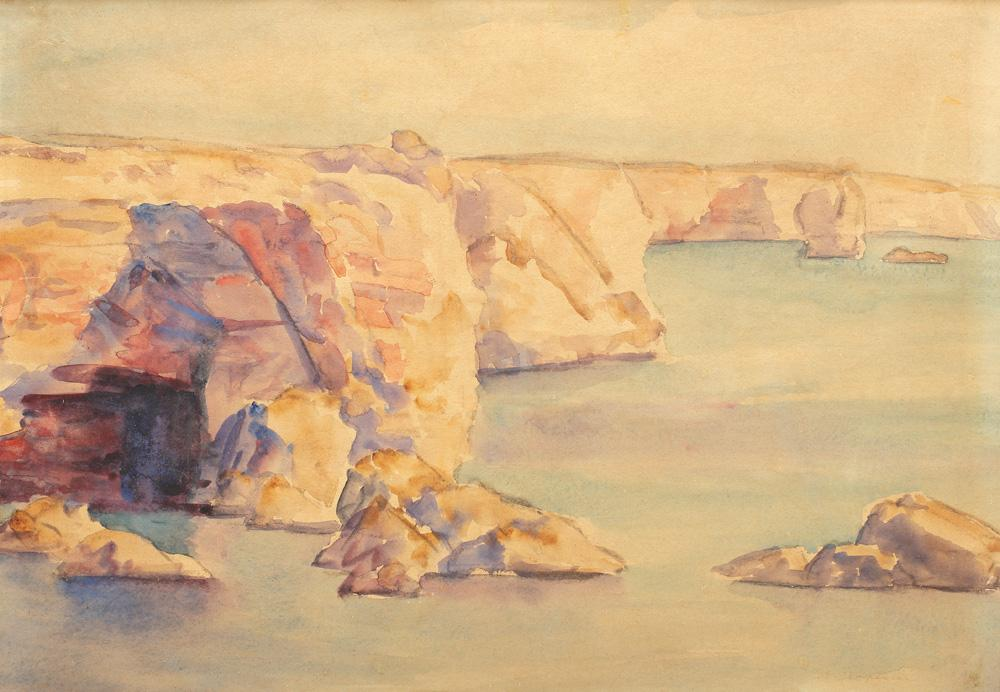Describe the following image. The image is a captivating watercolor painting depicting a serene rocky coastline. The artist's impressionistic approach is evident through the loose, flowing brushstrokes and the harmonious blend of colors. Warm hues such as yellows, oranges, and reds dominate the painting, evoking a sense of warmth and sunlight that bathes the rocky cliffs. These warm tones beautifully contrast with the cooler blues and greens of the tranquil sea, creating a visually striking composition. The artist's skillful manipulation of watercolors gives life to the landscape, making the rocks appear solid yet ethereal, and the water serene yet dynamic. This painting falls under the landscape or seascape genre, celebrating the natural beauty of the coastal scenery. Overall, it is a mesmerizing piece of art that invites the viewer to experience the tranquility and majesty of the seashore. 